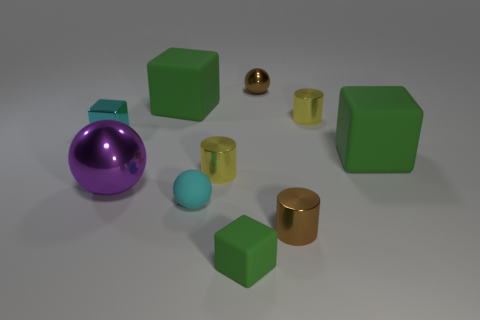Subtract all red balls. How many green cubes are left? 3 Subtract all cylinders. How many objects are left? 7 Add 6 brown metal cylinders. How many brown metal cylinders exist? 7 Subtract 2 yellow cylinders. How many objects are left? 8 Subtract all tiny yellow metallic cylinders. Subtract all small cyan rubber things. How many objects are left? 7 Add 2 spheres. How many spheres are left? 5 